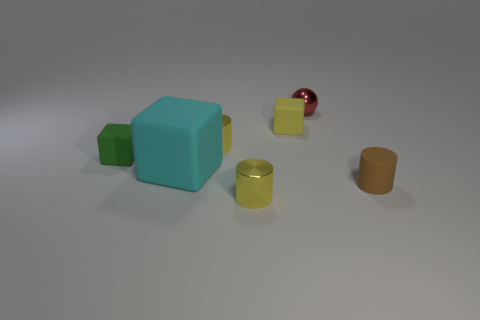How big is the metallic sphere?
Offer a very short reply. Small. How many red spheres have the same size as the yellow block?
Keep it short and to the point. 1. What number of brown objects have the same shape as the red shiny object?
Provide a succinct answer. 0. Are there an equal number of tiny brown rubber things on the left side of the small green cube and cyan rubber objects?
Your answer should be compact. No. Is there any other thing that is the same size as the red sphere?
Provide a short and direct response. Yes. What shape is the yellow matte object that is the same size as the red metal thing?
Your answer should be very brief. Cube. Are there any other matte things that have the same shape as the tiny yellow matte object?
Give a very brief answer. Yes. Are there any tiny yellow matte objects that are left of the yellow metal object that is behind the small matte object that is on the left side of the large block?
Keep it short and to the point. No. Is the number of red spheres that are behind the sphere greater than the number of brown matte cylinders that are left of the small matte cylinder?
Your answer should be compact. No. What material is the yellow block that is the same size as the red sphere?
Your answer should be compact. Rubber. 